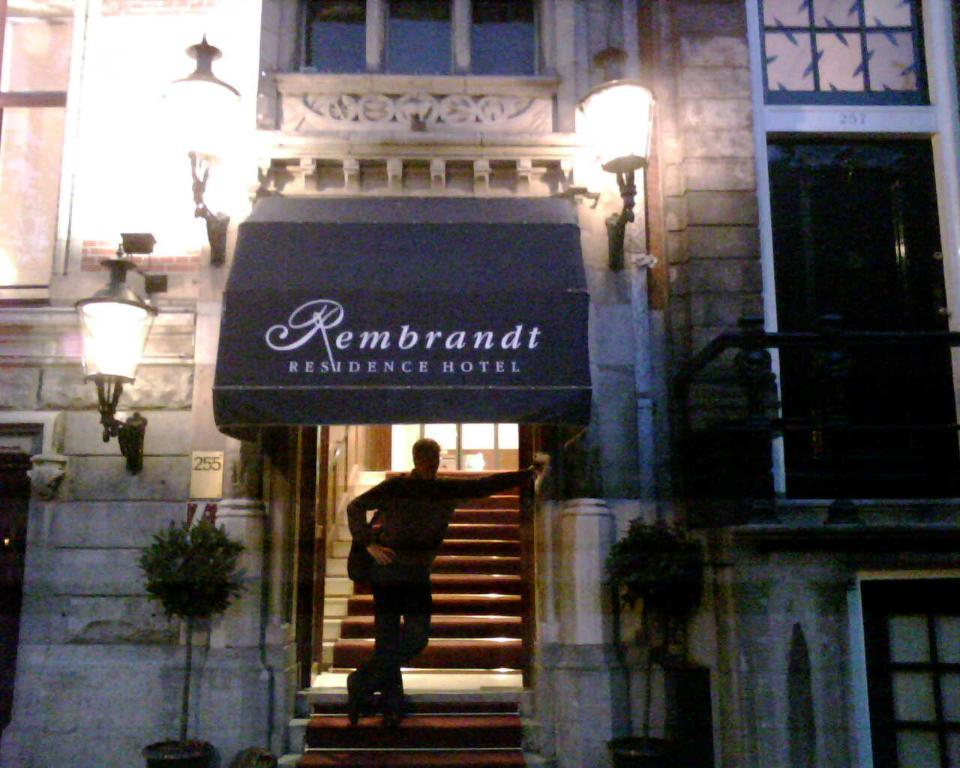What type of structure is visible in the image? There is a building in the image. What can be seen in front of the building? There are lights and an object with a label in front of the building. Is there anyone near the building? Yes, a person is standing at the entrance of the building. What type of pet can be seen playing with a quarter in front of the building? There is no pet or quarter present in the image. 